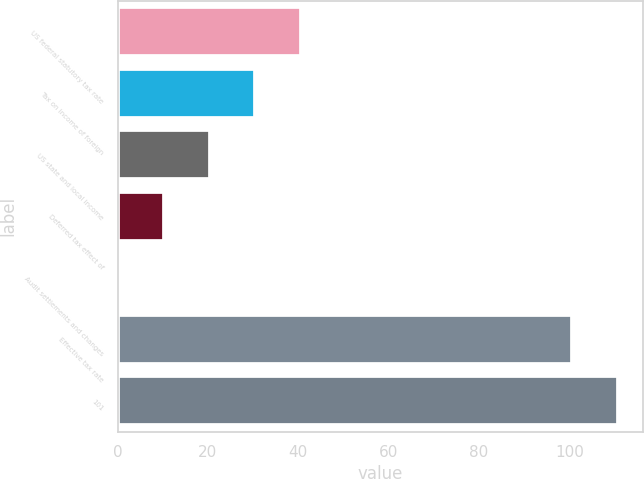Convert chart. <chart><loc_0><loc_0><loc_500><loc_500><bar_chart><fcel>US federal statutory tax rate<fcel>Tax on income of foreign<fcel>US state and local income<fcel>Deferred tax effect of<fcel>Audit settlements and changes<fcel>Effective tax rate<fcel>101<nl><fcel>40.52<fcel>30.44<fcel>20.36<fcel>10.28<fcel>0.2<fcel>100.6<fcel>110.68<nl></chart> 